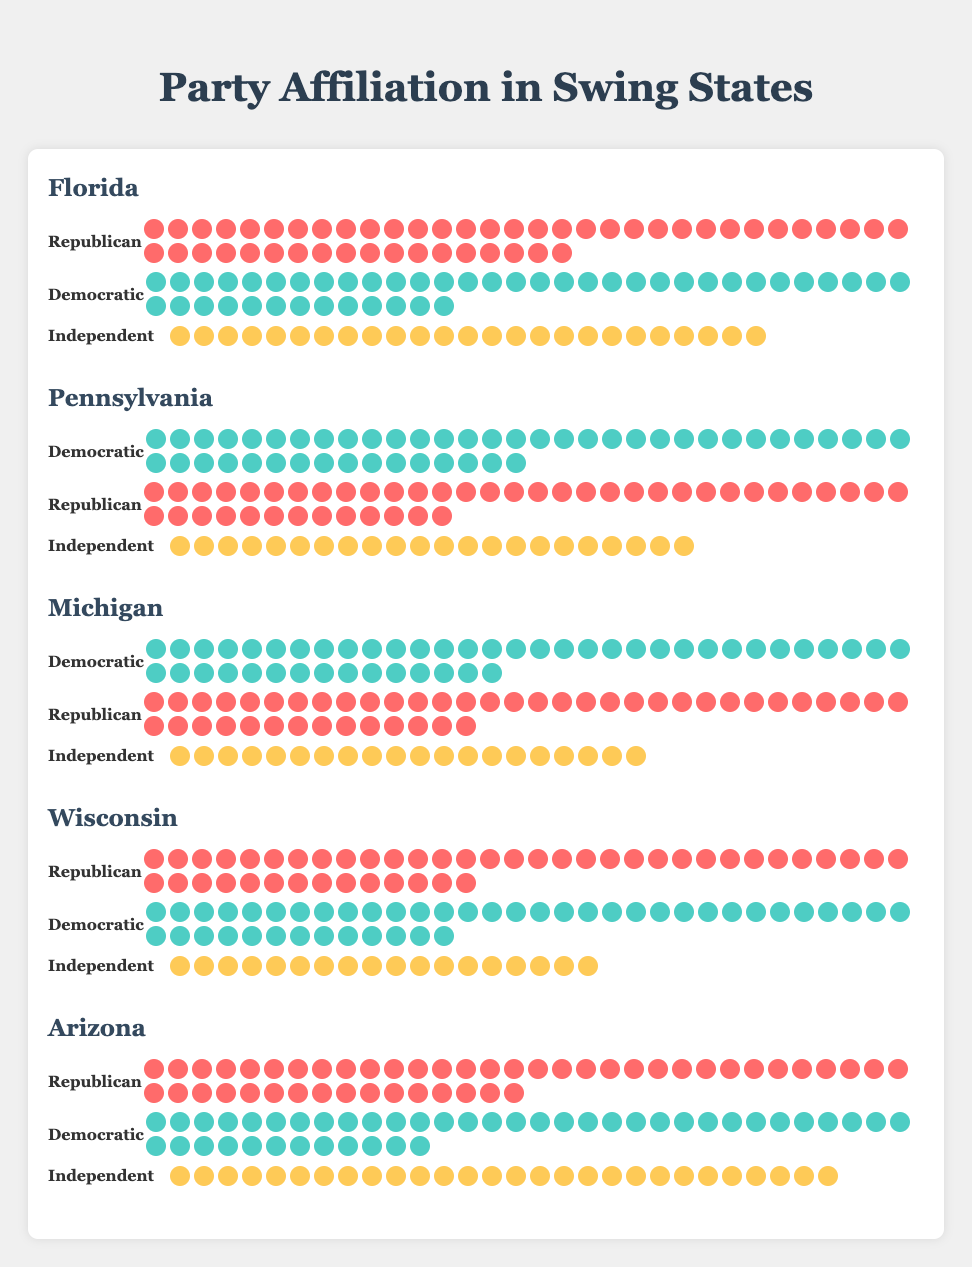What is the title of the figure? The title is usually located at the top of the figure in a larger or bold font. In this case, the title is "Party Affiliation in Swing States" as stated in the heading.
Answer: Party Affiliation in Swing States Which state has the most Republican voters shown in the figure? By comparing the size of the red (Republican) icons in each state, Arizona has the most Republican voters, with 48 icons.
Answer: Arizona How many more independent voters are there in Florida compared to Wisconsin? Florida has 25 independent voters, while Wisconsin has 18. The difference is 25 - 18 = 7.
Answer: 7 Which state has the least number of independent voters? We compare the number of yellow (Independent) icons across all states. Wisconsin, with 18 independent voters, has the least.
Answer: Wisconsin How do the Democratic and Republican voter numbers compare in Pennsylvania? Pennsylvania has 48 Democratic voters and 45 Republican voters. The Democratic voters are higher by 3.
Answer: Democratic voters are higher by 3 What is the total number of voters in Michigan? Adding up all the voter counts in Michigan: 47 (Democratic) + 46 (Republican) + 20 (Independent) equals 113.
Answer: 113 Which state has almost equal numbers of Democratic and Republican voters? By checking the voter counts, Michigan has a close count with 47 Democratic and 46 Republican voters.
Answer: Michigan What visual feature distinguishes different parties in the figure? Colors distinguish the different parties: red for Republican, blue for Democratic, and yellow for Independent. This helps quickly identify party afiliations.
Answer: Colors Can you rank the states based on the number of Independent voters from highest to lowest? By comparing the number of yellow icons, the ranking is: 1. Arizona (28) 2. Florida (25) 3. Pennsylvania (22) 4. Michigan (20) 5. Wisconsin (18).
Answer: 1. Arizona, 2. Florida, 3. Pennsylvania, 4. Michigan, 5. Wisconsin How many swing states are illustrated in the figure? The figure depicts 5 different swing states, listed under the heading.
Answer: 5 